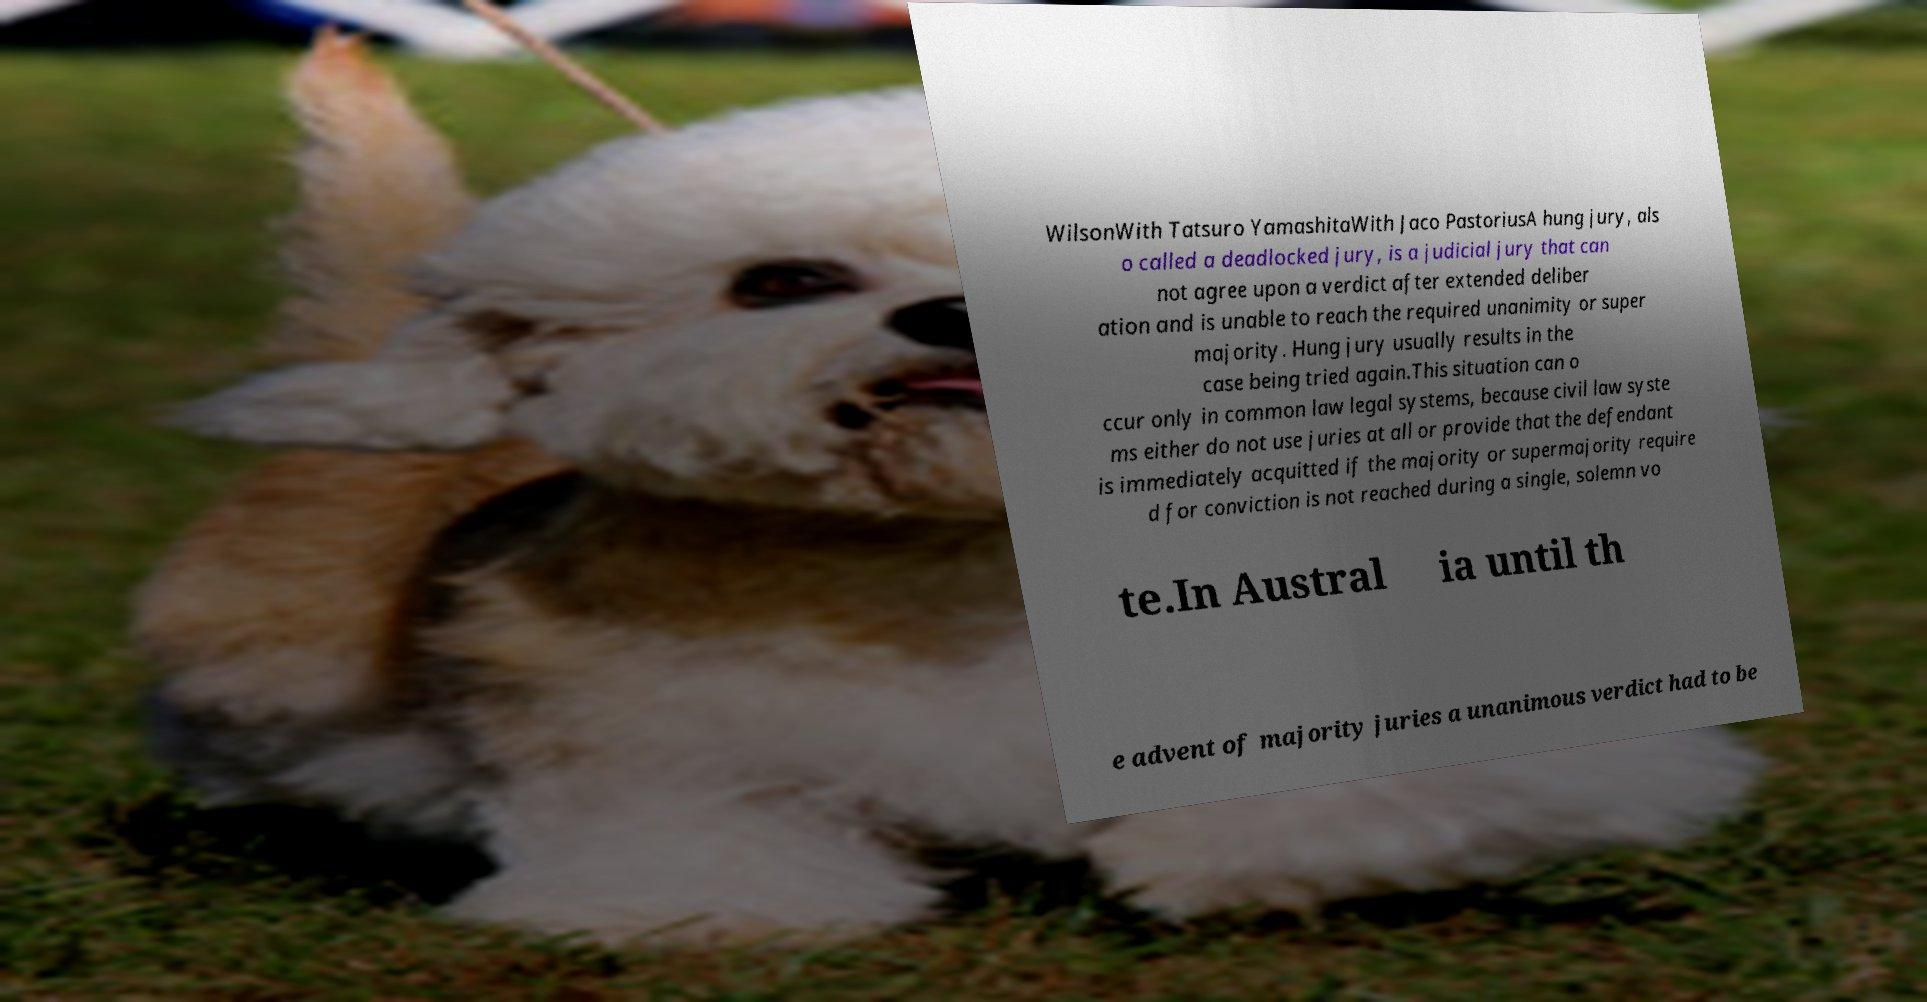I need the written content from this picture converted into text. Can you do that? WilsonWith Tatsuro YamashitaWith Jaco PastoriusA hung jury, als o called a deadlocked jury, is a judicial jury that can not agree upon a verdict after extended deliber ation and is unable to reach the required unanimity or super majority. Hung jury usually results in the case being tried again.This situation can o ccur only in common law legal systems, because civil law syste ms either do not use juries at all or provide that the defendant is immediately acquitted if the majority or supermajority require d for conviction is not reached during a single, solemn vo te.In Austral ia until th e advent of majority juries a unanimous verdict had to be 